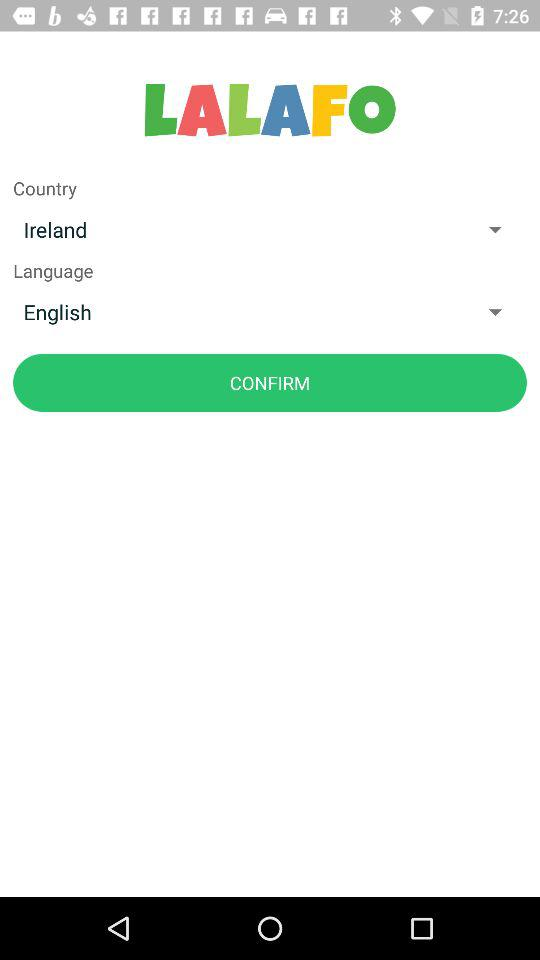Which country is selected? The selected country is Ireland. 